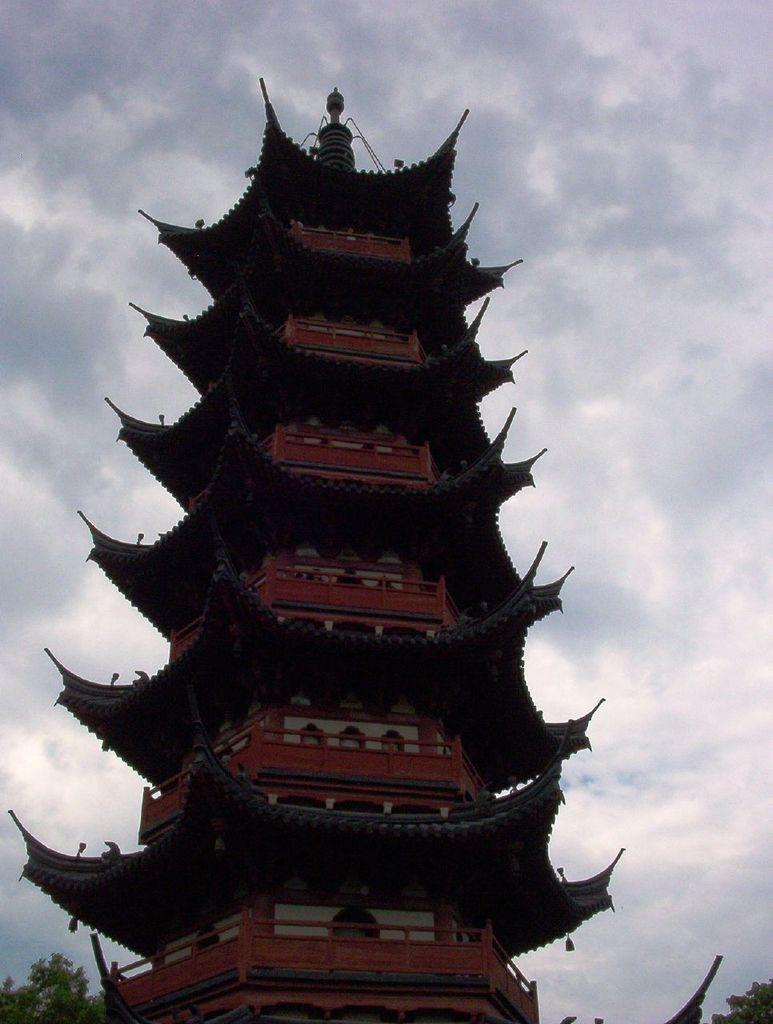What type of structure is visible in the image? There is a building in the image. What can be seen on the left side of the image? There are trees on the left side of the image. What can be seen on the right side of the image? There are trees on the right side of the image. What is visible in the background of the image? The sky is visible in the image. What can be observed in the sky? Clouds are present in the sky. What is located at the bottom of the image? There is an object at the bottom of the image. How many eyes can be seen on the ladybug in the image? There is no ladybug present in the image, so it is not possible to determine the number of eyes. 